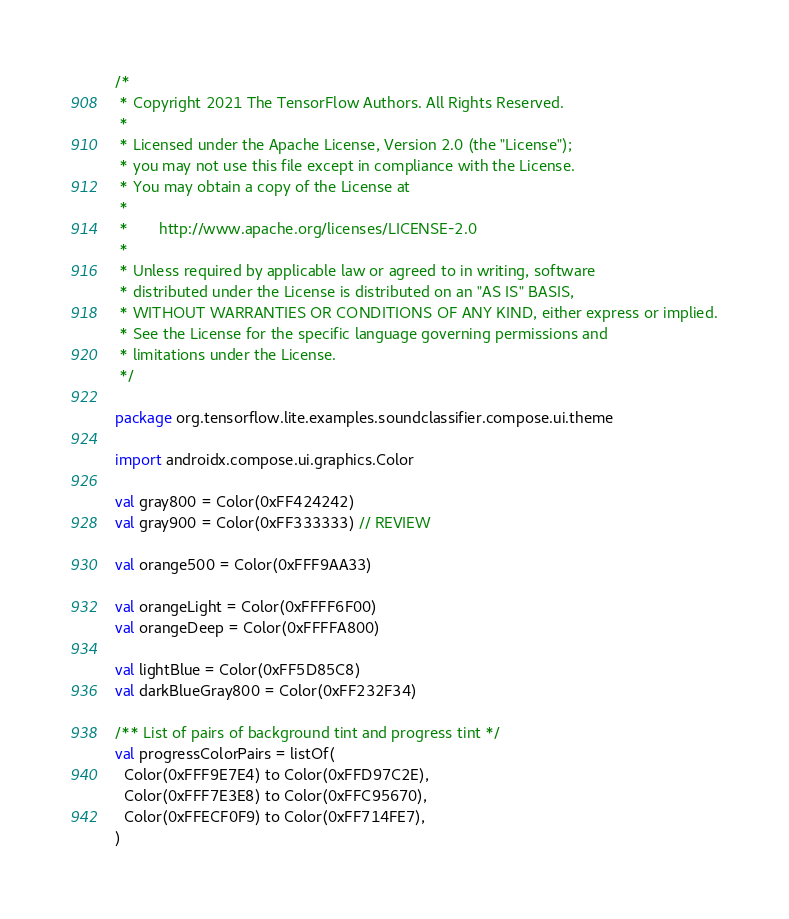Convert code to text. <code><loc_0><loc_0><loc_500><loc_500><_Kotlin_>/*
 * Copyright 2021 The TensorFlow Authors. All Rights Reserved.
 *
 * Licensed under the Apache License, Version 2.0 (the "License");
 * you may not use this file except in compliance with the License.
 * You may obtain a copy of the License at
 *
 *       http://www.apache.org/licenses/LICENSE-2.0
 *
 * Unless required by applicable law or agreed to in writing, software
 * distributed under the License is distributed on an "AS IS" BASIS,
 * WITHOUT WARRANTIES OR CONDITIONS OF ANY KIND, either express or implied.
 * See the License for the specific language governing permissions and
 * limitations under the License.
 */

package org.tensorflow.lite.examples.soundclassifier.compose.ui.theme

import androidx.compose.ui.graphics.Color

val gray800 = Color(0xFF424242)
val gray900 = Color(0xFF333333) // REVIEW

val orange500 = Color(0xFFF9AA33)

val orangeLight = Color(0xFFFF6F00)
val orangeDeep = Color(0xFFFFA800)

val lightBlue = Color(0xFF5D85C8)
val darkBlueGray800 = Color(0xFF232F34)

/** List of pairs of background tint and progress tint */
val progressColorPairs = listOf(
  Color(0xFFF9E7E4) to Color(0xFFD97C2E),
  Color(0xFFF7E3E8) to Color(0xFFC95670),
  Color(0xFFECF0F9) to Color(0xFF714FE7),
)
</code> 